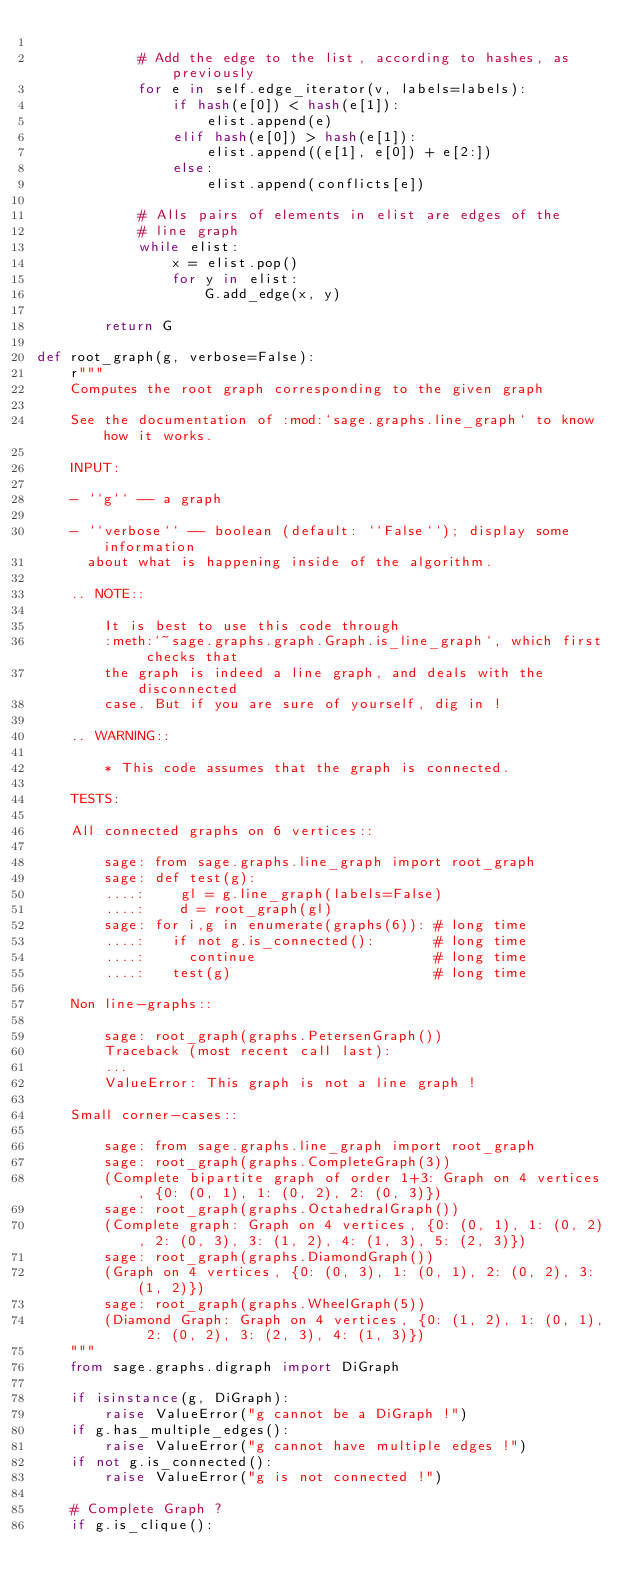Convert code to text. <code><loc_0><loc_0><loc_500><loc_500><_Python_>
            # Add the edge to the list, according to hashes, as previously
            for e in self.edge_iterator(v, labels=labels):
                if hash(e[0]) < hash(e[1]):
                    elist.append(e)
                elif hash(e[0]) > hash(e[1]):
                    elist.append((e[1], e[0]) + e[2:])
                else:
                    elist.append(conflicts[e])

            # Alls pairs of elements in elist are edges of the
            # line graph
            while elist:
                x = elist.pop()
                for y in elist:
                    G.add_edge(x, y)

        return G

def root_graph(g, verbose=False):
    r"""
    Computes the root graph corresponding to the given graph

    See the documentation of :mod:`sage.graphs.line_graph` to know how it works.

    INPUT:

    - ``g`` -- a graph

    - ``verbose`` -- boolean (default: ``False``); display some information
      about what is happening inside of the algorithm.

    .. NOTE::

        It is best to use this code through
        :meth:`~sage.graphs.graph.Graph.is_line_graph`, which first checks that
        the graph is indeed a line graph, and deals with the disconnected
        case. But if you are sure of yourself, dig in !

    .. WARNING::

        * This code assumes that the graph is connected.

    TESTS:

    All connected graphs on 6 vertices::

        sage: from sage.graphs.line_graph import root_graph
        sage: def test(g):
        ....:    gl = g.line_graph(labels=False)
        ....:    d = root_graph(gl)
        sage: for i,g in enumerate(graphs(6)): # long time
        ....:   if not g.is_connected():       # long time
        ....:     continue                     # long time
        ....:   test(g)                        # long time

    Non line-graphs::

        sage: root_graph(graphs.PetersenGraph())
        Traceback (most recent call last):
        ...
        ValueError: This graph is not a line graph !

    Small corner-cases::

        sage: from sage.graphs.line_graph import root_graph
        sage: root_graph(graphs.CompleteGraph(3))
        (Complete bipartite graph of order 1+3: Graph on 4 vertices, {0: (0, 1), 1: (0, 2), 2: (0, 3)})
        sage: root_graph(graphs.OctahedralGraph())
        (Complete graph: Graph on 4 vertices, {0: (0, 1), 1: (0, 2), 2: (0, 3), 3: (1, 2), 4: (1, 3), 5: (2, 3)})
        sage: root_graph(graphs.DiamondGraph())
        (Graph on 4 vertices, {0: (0, 3), 1: (0, 1), 2: (0, 2), 3: (1, 2)})
        sage: root_graph(graphs.WheelGraph(5))
        (Diamond Graph: Graph on 4 vertices, {0: (1, 2), 1: (0, 1), 2: (0, 2), 3: (2, 3), 4: (1, 3)})
    """
    from sage.graphs.digraph import DiGraph

    if isinstance(g, DiGraph):
        raise ValueError("g cannot be a DiGraph !")
    if g.has_multiple_edges():
        raise ValueError("g cannot have multiple edges !")
    if not g.is_connected():
        raise ValueError("g is not connected !")

    # Complete Graph ?
    if g.is_clique():</code> 